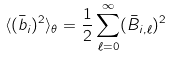<formula> <loc_0><loc_0><loc_500><loc_500>\langle ( \bar { b } _ { i } ) ^ { 2 } \rangle _ { \theta } = \frac { 1 } { 2 } \sum _ { \ell = 0 } ^ { \infty } ( \bar { B } _ { i , \ell } ) ^ { 2 }</formula> 